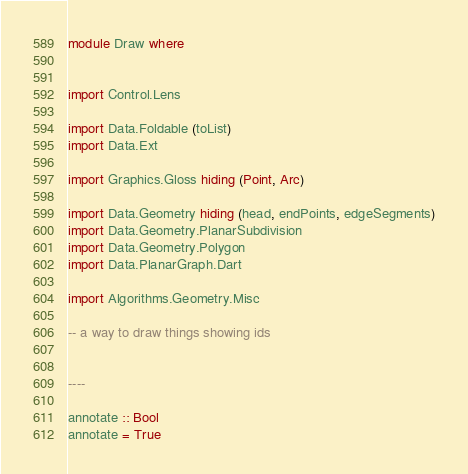<code> <loc_0><loc_0><loc_500><loc_500><_Haskell_>module Draw where


import Control.Lens

import Data.Foldable (toList)
import Data.Ext

import Graphics.Gloss hiding (Point, Arc)

import Data.Geometry hiding (head, endPoints, edgeSegments)
import Data.Geometry.PlanarSubdivision
import Data.Geometry.Polygon
import Data.PlanarGraph.Dart

import Algorithms.Geometry.Misc

-- a way to draw things showing ids


----

annotate :: Bool
annotate = True
</code> 